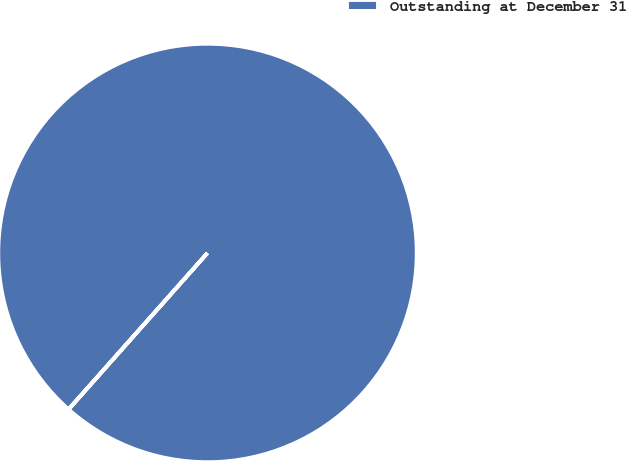<chart> <loc_0><loc_0><loc_500><loc_500><pie_chart><fcel>Outstanding at December 31<nl><fcel>100.0%<nl></chart> 